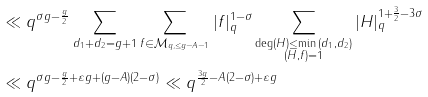<formula> <loc_0><loc_0><loc_500><loc_500>& \ll q ^ { \sigma g - \frac { g } { 2 } } \sum _ { d _ { 1 } + d _ { 2 } = g + 1 } \sum _ { f \in \mathcal { M } _ { q , \leq g - A - 1 } } | f | _ { q } ^ { 1 - \sigma } \sum _ { \substack { \deg ( H ) \leq \min { ( d _ { 1 } , d _ { 2 } ) } \\ ( H , f ) = 1 } } | H | _ { q } ^ { 1 + \frac { 3 } { 2 } - 3 \sigma } \\ & \ll q ^ { \sigma g - \frac { g } { 2 } + \varepsilon g + ( g - A ) ( 2 - \sigma ) } \ll q ^ { \frac { 3 g } { 2 } - A ( 2 - \sigma ) + \varepsilon g }</formula> 